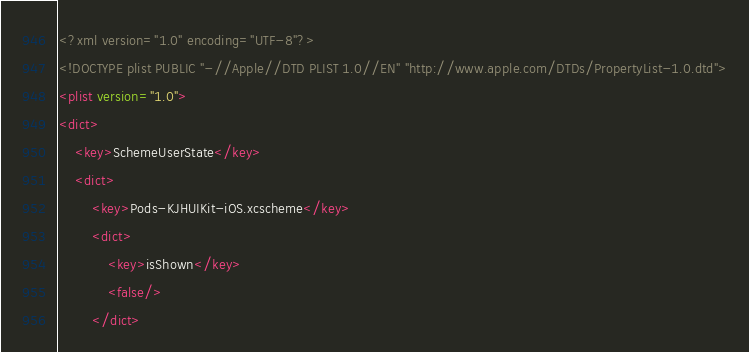<code> <loc_0><loc_0><loc_500><loc_500><_XML_><?xml version="1.0" encoding="UTF-8"?>
<!DOCTYPE plist PUBLIC "-//Apple//DTD PLIST 1.0//EN" "http://www.apple.com/DTDs/PropertyList-1.0.dtd">
<plist version="1.0">
<dict>
	<key>SchemeUserState</key>
	<dict>
		<key>Pods-KJHUIKit-iOS.xcscheme</key>
		<dict>
			<key>isShown</key>
			<false/>
		</dict></code> 